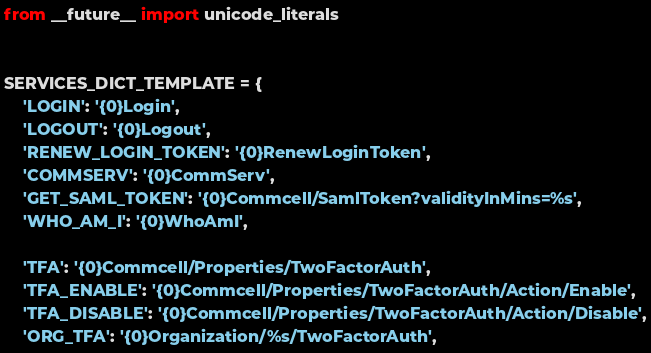Convert code to text. <code><loc_0><loc_0><loc_500><loc_500><_Python_>from __future__ import unicode_literals


SERVICES_DICT_TEMPLATE = {
    'LOGIN': '{0}Login',
    'LOGOUT': '{0}Logout',
    'RENEW_LOGIN_TOKEN': '{0}RenewLoginToken',
    'COMMSERV': '{0}CommServ',
    'GET_SAML_TOKEN': '{0}Commcell/SamlToken?validityInMins=%s',
    'WHO_AM_I': '{0}WhoAmI',

    'TFA': '{0}Commcell/Properties/TwoFactorAuth',
    'TFA_ENABLE': '{0}Commcell/Properties/TwoFactorAuth/Action/Enable',
    'TFA_DISABLE': '{0}Commcell/Properties/TwoFactorAuth/Action/Disable',
    'ORG_TFA': '{0}Organization/%s/TwoFactorAuth',</code> 